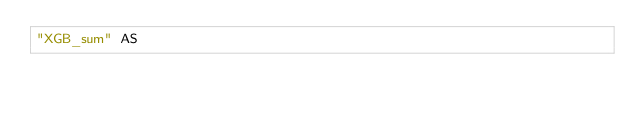<code> <loc_0><loc_0><loc_500><loc_500><_SQL_>"XGB_sum" AS </code> 